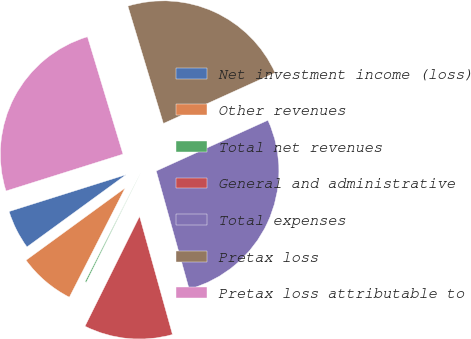Convert chart. <chart><loc_0><loc_0><loc_500><loc_500><pie_chart><fcel>Net investment income (loss)<fcel>Other revenues<fcel>Total net revenues<fcel>General and administrative<fcel>Total expenses<fcel>Pretax loss<fcel>Pretax loss attributable to<nl><fcel>5.17%<fcel>7.46%<fcel>0.18%<fcel>11.66%<fcel>27.46%<fcel>22.89%<fcel>25.18%<nl></chart> 